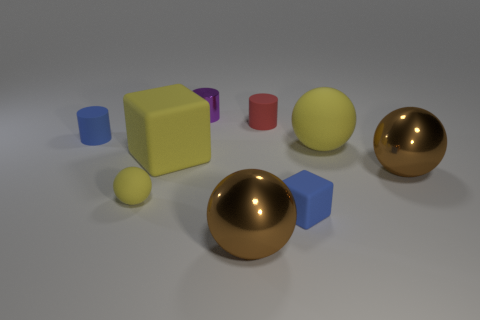There is a big matte thing that is in front of the big yellow ball; does it have the same shape as the blue rubber object that is on the right side of the small purple shiny thing?
Offer a terse response. Yes. How many other things are there of the same material as the large yellow block?
Give a very brief answer. 5. There is a blue matte thing that is in front of the large yellow matte thing on the left side of the purple metallic object; are there any matte blocks behind it?
Make the answer very short. Yes. Is the material of the red cylinder the same as the purple object?
Provide a short and direct response. No. There is a block that is right of the shiny sphere in front of the tiny yellow sphere; what is its material?
Ensure brevity in your answer.  Rubber. What size is the yellow rubber block behind the small yellow rubber sphere?
Offer a very short reply. Large. The small object that is on the right side of the small purple shiny cylinder and behind the large yellow block is what color?
Provide a succinct answer. Red. There is a shiny thing that is to the right of the red rubber thing; does it have the same size as the large yellow rubber cube?
Your response must be concise. Yes. Is there a rubber ball that is to the right of the yellow ball on the left side of the yellow matte block?
Your answer should be very brief. Yes. What material is the big yellow ball?
Give a very brief answer. Rubber. 